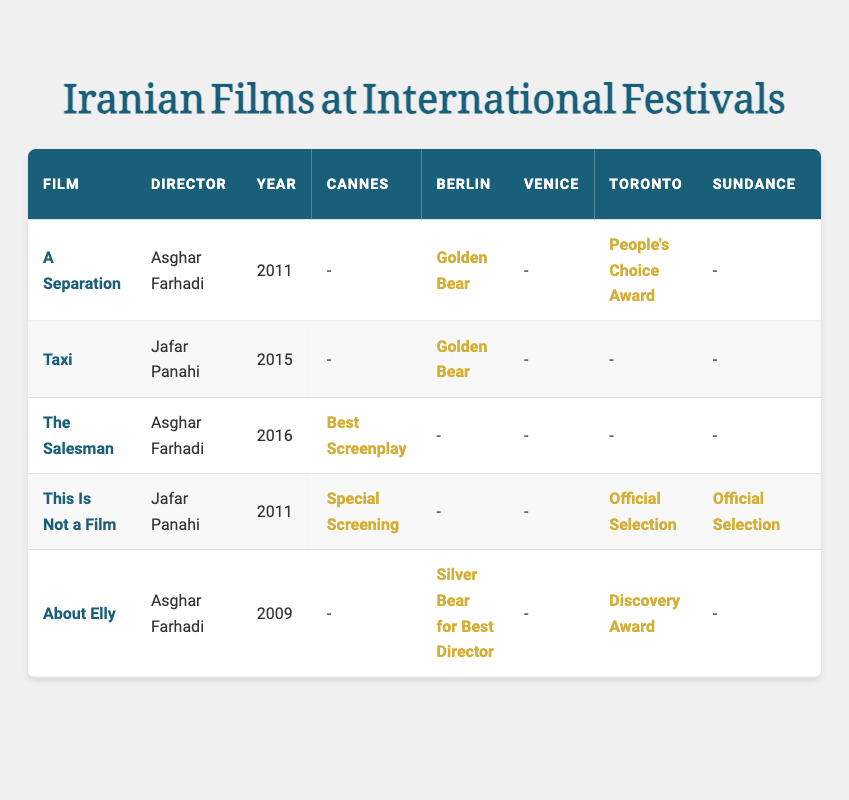What is the highest critical score among the films listed? The critical scores can be found in the last column for each film. The highest score is 98, which corresponds to the film "This Is Not a Film."
Answer: 98 Which film won the Golden Bear at the Berlin International Film Festival? The Golden Bear was awarded to "A Separation" and "Taxi." Both films can be found in the Berlin column under awards.
Answer: A Separation and Taxi How many films received awards at the Cannes Film Festival? By reviewing the Cannes column for awards, it's clear that "The Salesman," "This Is Not a Film," and "A Separation" received awards, totaling three films.
Answer: 3 Which director has made the film with the highest critical score? The film with the highest critical score (98) is directed by Jafar Panahi, as it falls under his film "This Is Not a Film."
Answer: Jafar Panahi Was "About Elly" recognized at both the Berlin and Toronto International Film Festivals? Yes, "About Elly" received the Silver Bear for Best Director at the Berlin International Film Festival and the Discovery Award at the Toronto International Film Festival, indicating recognition at both festivals.
Answer: Yes Which film has the lowest critical score and what is it? The lowest critical score can be found by reviewing the scores in the last column. The film "About Elly" has a score of 87, which is the lowest.
Answer: 87 What is the total number of awards won by Asghar Farhadi's films? Asghar Farhadi's films include "A Separation," which has 2 awards (Berlin and Toronto), "The Salesman" with 1 award (Cannes), and "About Elly," with 1 award (Berlin). Adding these gives a total of 4 awards.
Answer: 4 Is there any film that received recognition at both the Venice and Toronto International Film Festivals? No, examining the awards columns for both Venice and Toronto confirms that no film is listed as receiving awards at both festivals.
Answer: No 